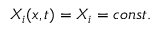<formula> <loc_0><loc_0><loc_500><loc_500>X _ { i } ( x , t ) = X _ { i } = c o n s t .</formula> 